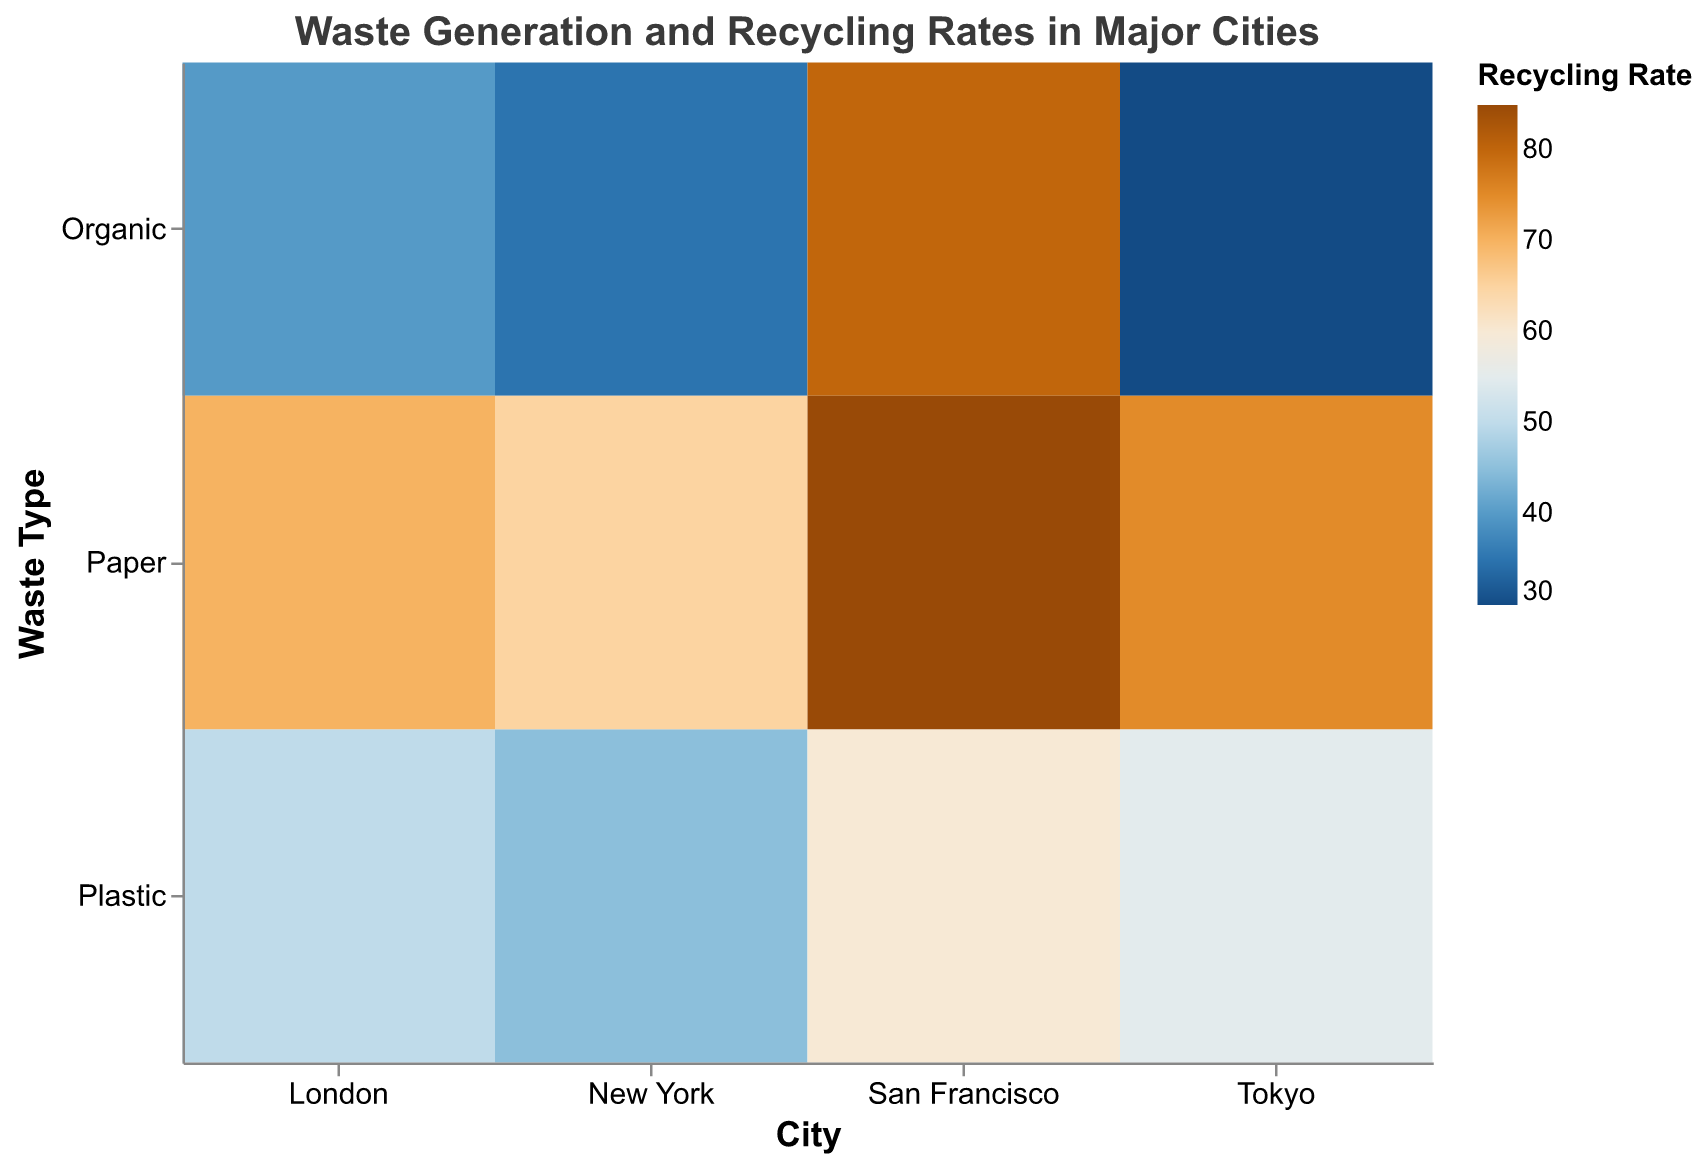Which city has the highest recycling rate for organic waste? Observe the color intensity in the 'Organic' row across all cities. San Francisco's segment is the most intensely colored, indicating the highest recycling rate.
Answer: San Francisco How much waste does Tokyo generate annually for paper? Look at the size of the rectangle in the 'Paper' row for Tokyo. It corresponds to 1,200,000 tons/year according to the legend.
Answer: 1,200,000 tons Among all cities, which one has the lowest recycling rate for plastic waste? Focus on the 'Plastic' row across all cities and compare the colors. New York has the least intense color in this row, indicating the lowest recycling rate.
Answer: New York Which city generates the most organic waste annually? Compare the sizes of rectangles in the 'Organic' row. Tokyo has the largest rectangle in this row, indicating the highest waste generation.
Answer: Tokyo Which waste type in San Francisco has the highest recycling rate and what is the rate? In the 'San Francisco' column, the most intensely colored rectangle is in the 'Paper' row. Its recycling rate is 85%.
Answer: Paper, 85% How does New York's recycling rate for paper compare to London's? Check the 'Paper' row for both New York and London, and compare the color intensities. New York's paper recycling rate (more intense color) is higher than London's.
Answer: New York is higher than London What is the average recycling rate for plastic waste among all cities? Add up the recycling rates for plastic waste across all cities and divide by the number of cities (45% + 60% + 50% + 55%) / 4 = 52.5%.
Answer: 52.5% Which city has the smallest difference in recycling rates between organic and plastic waste? Calculate the differences: New York (45-35)=10, San Francisco (80-60)=20, London (50-40)=10, Tokyo (55-30)=25. New York and London both have a difference of 10%.
Answer: New York or London Which city generates the least plastic waste annually and what is the amount? Compare the sizes of rectangles in the 'Plastic' row and identify the smallest one. San Francisco has the smallest rectangle, indicating 300,000 tons/year.
Answer: San Francisco, 300,000 tons In which city does paper have the highest recycling rate relative to other waste types? For each city, compare recycling rates across waste types and identify the highest. In San Francisco, paper has the highest rate among organic, plastic, and paper waste (85%).
Answer: San Francisco 